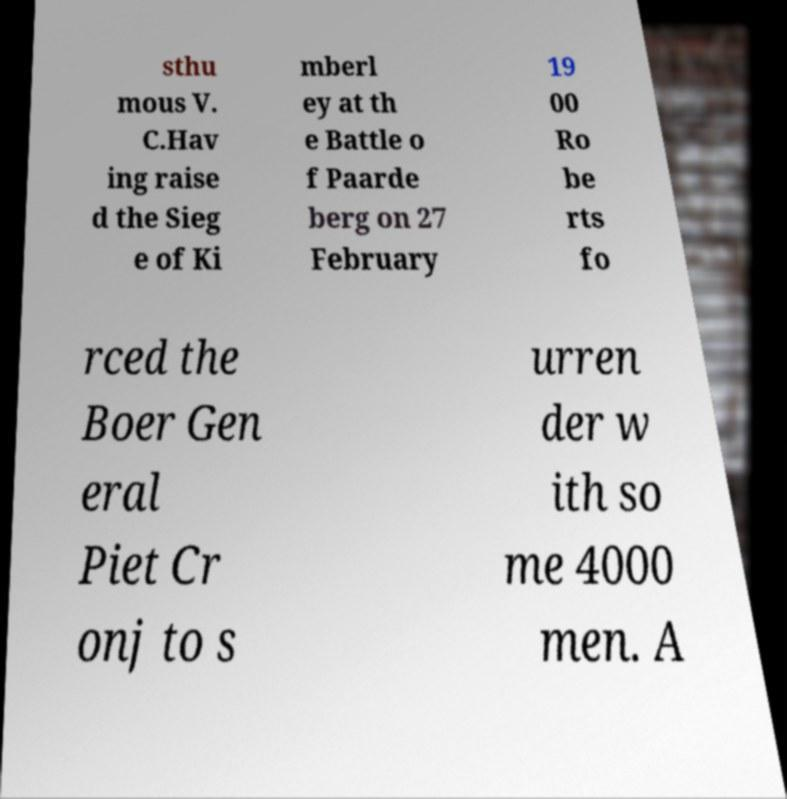There's text embedded in this image that I need extracted. Can you transcribe it verbatim? sthu mous V. C.Hav ing raise d the Sieg e of Ki mberl ey at th e Battle o f Paarde berg on 27 February 19 00 Ro be rts fo rced the Boer Gen eral Piet Cr onj to s urren der w ith so me 4000 men. A 